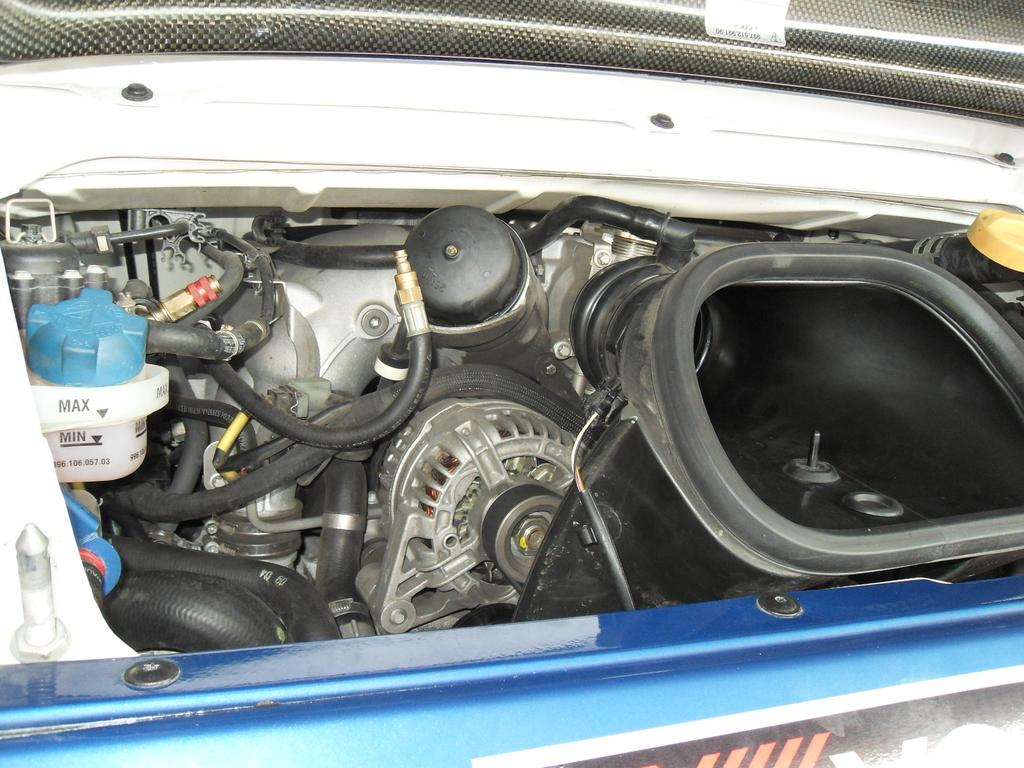What type of liquid is present in the image? There is a coolant in the image. What color are the tubes in the image? The tubes in the image are black. What component is used for heat dissipation in the image? There is a radiator in the image. What is the box-shaped object in the image? There is a turbo box in the image. Where is the radiator grill located in the image? The radiator grill is at the bottom of the image. What type of spoon is used to stir the coolant in the image? There is no spoon present in the image; it is a mechanical system with coolant, tubes, a radiator, a turbo box, and a radiator grill. Is there a jail visible in the image? No, there is no jail present in the image. 